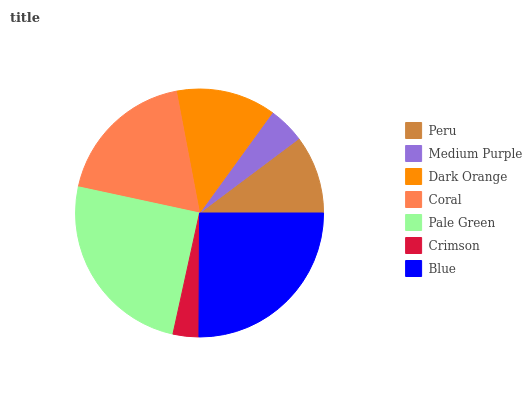Is Crimson the minimum?
Answer yes or no. Yes. Is Blue the maximum?
Answer yes or no. Yes. Is Medium Purple the minimum?
Answer yes or no. No. Is Medium Purple the maximum?
Answer yes or no. No. Is Peru greater than Medium Purple?
Answer yes or no. Yes. Is Medium Purple less than Peru?
Answer yes or no. Yes. Is Medium Purple greater than Peru?
Answer yes or no. No. Is Peru less than Medium Purple?
Answer yes or no. No. Is Dark Orange the high median?
Answer yes or no. Yes. Is Dark Orange the low median?
Answer yes or no. Yes. Is Blue the high median?
Answer yes or no. No. Is Crimson the low median?
Answer yes or no. No. 